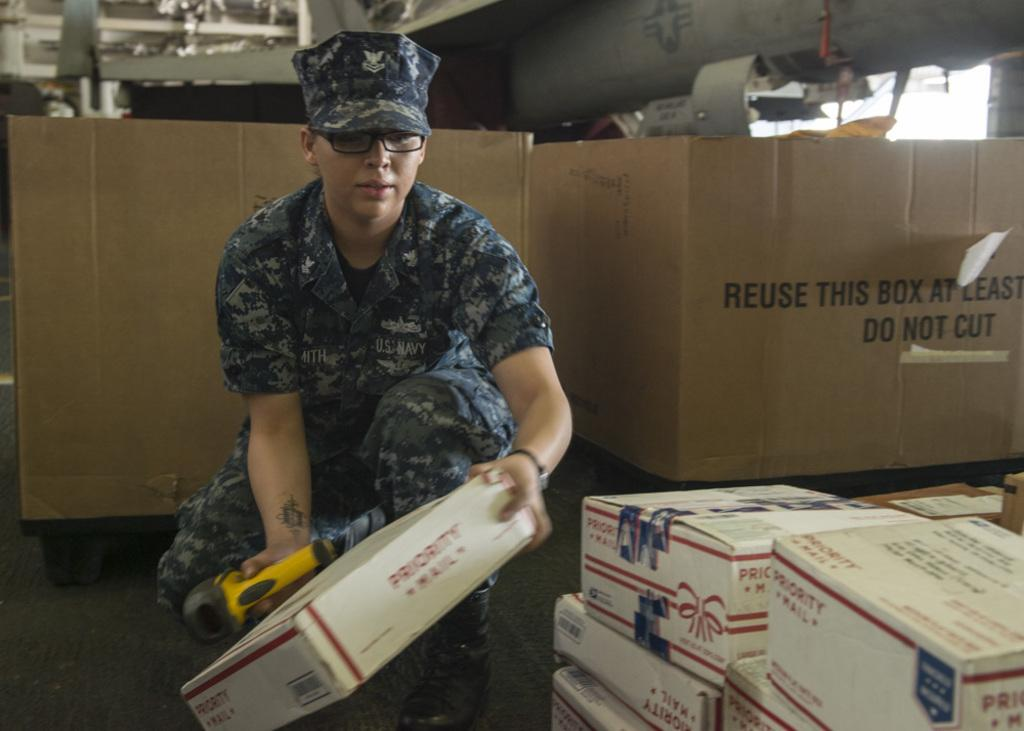<image>
Offer a succinct explanation of the picture presented. The soldier is handling  several Priority Mail boxes. 